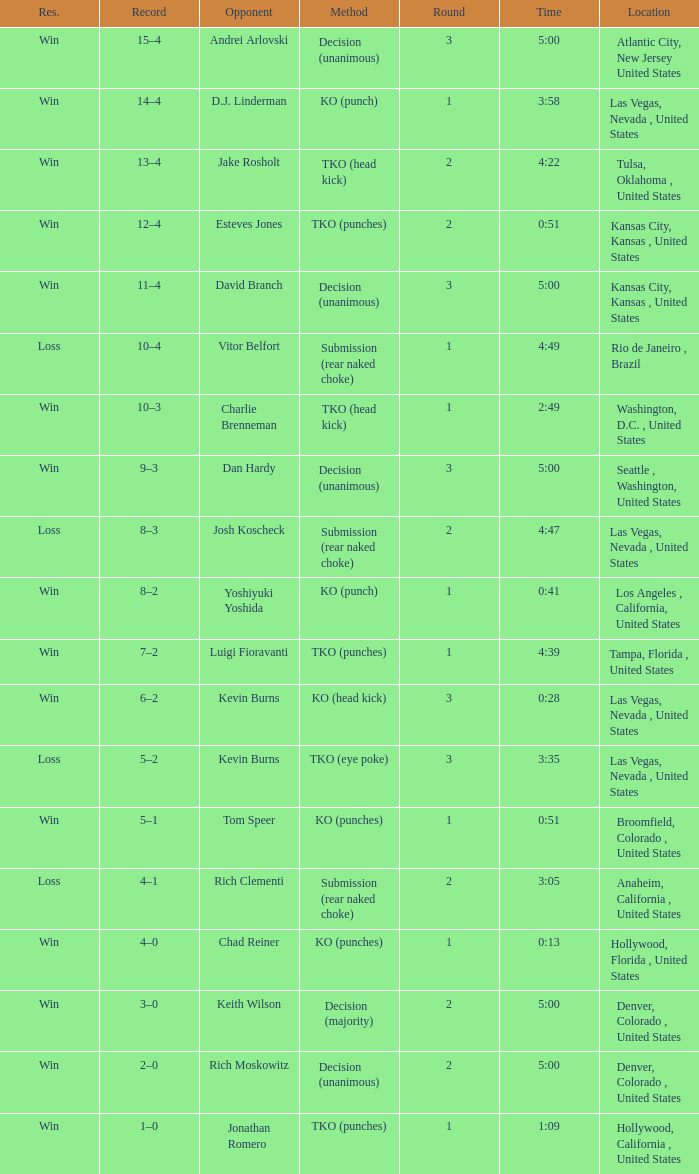What is the result for rounds under 2 against D.J. Linderman? Win. 